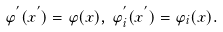<formula> <loc_0><loc_0><loc_500><loc_500>\varphi ^ { ^ { \prime } } ( x ^ { ^ { \prime } } ) = \varphi ( x ) , \, \varphi ^ { ^ { \prime } } _ { i } ( x ^ { ^ { \prime } } ) = \varphi _ { i } ( x ) .</formula> 